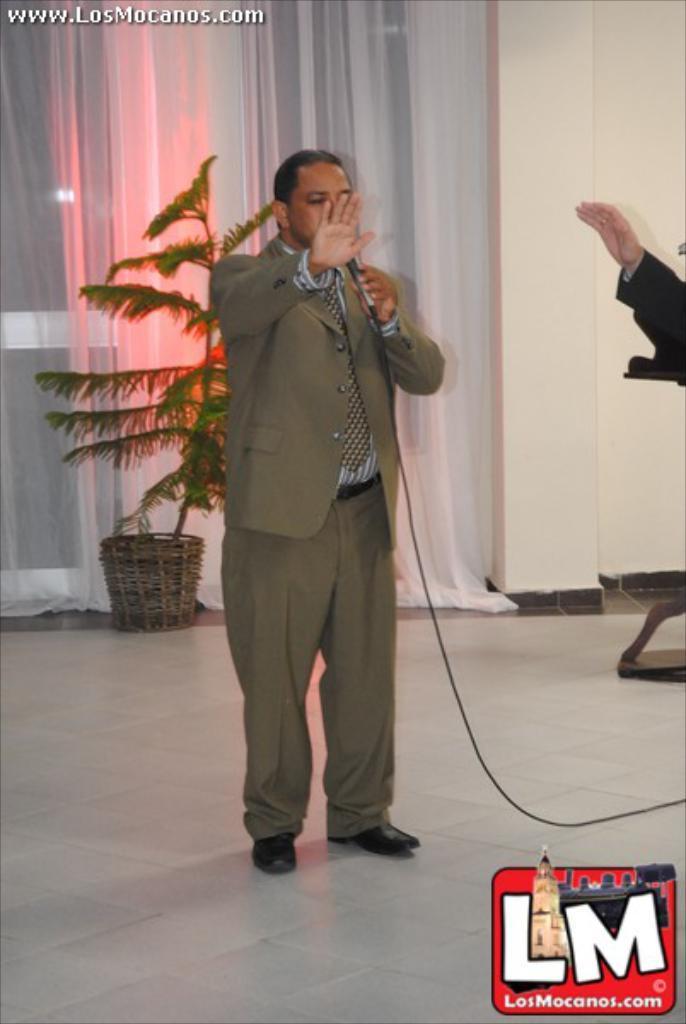How would you summarize this image in a sentence or two? A man is standing and speaking with a mic in his hand. He wears a suit and pant. There is plant behind him. There is a door with white curtains. There is a human hand on a side of image. 